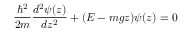Convert formula to latex. <formula><loc_0><loc_0><loc_500><loc_500>\frac { \hbar { ^ } { 2 } } { 2 m } \frac { d ^ { 2 } \psi ( z ) } { d z ^ { 2 } } + ( E - m g z ) \psi ( z ) = 0</formula> 